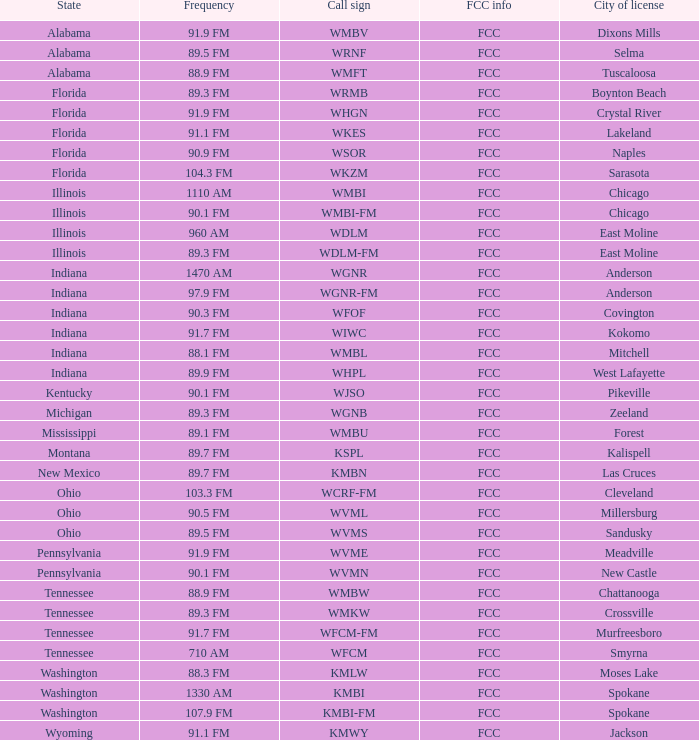What is the call sign for 90.9 FM which is in Florida? WSOR. 